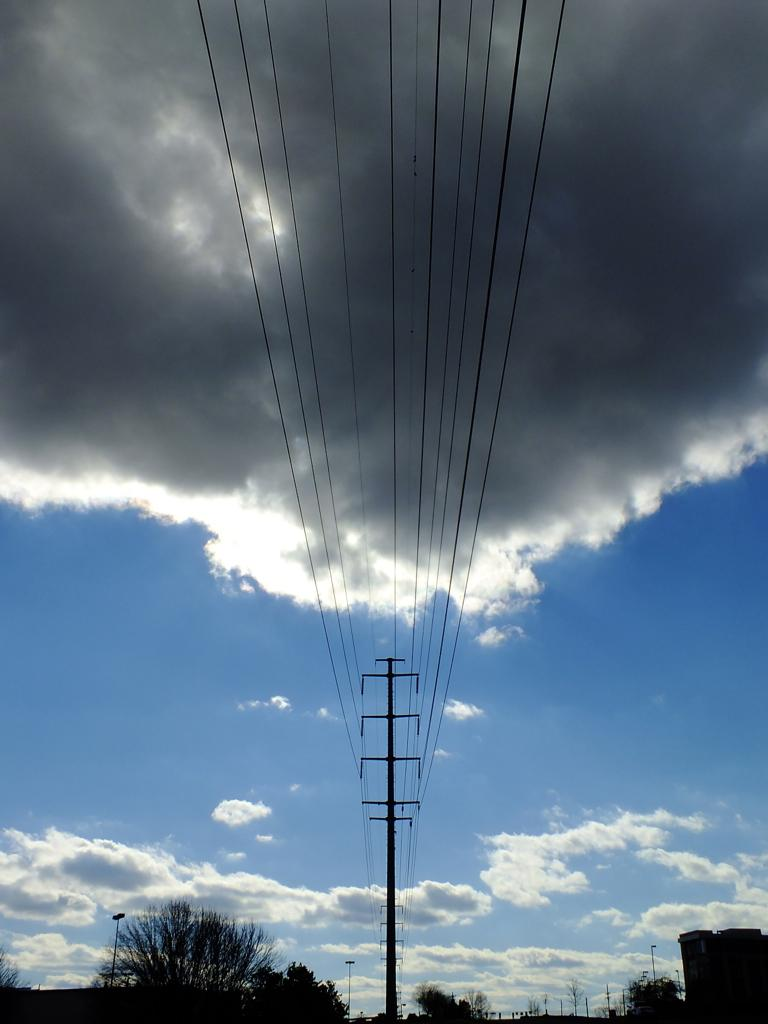What is connecting the poles in the image? Wires are connecting the poles in the image. What can be seen at the bottom of the image? There are trees and buildings at the bottom of the image. What is visible in the background of the image? The background of the image includes the sky. What can be observed in the sky in the image? There are clouds in the sky. What type of stove is being used by the representative in the image? There is no representative or stove present in the image. 